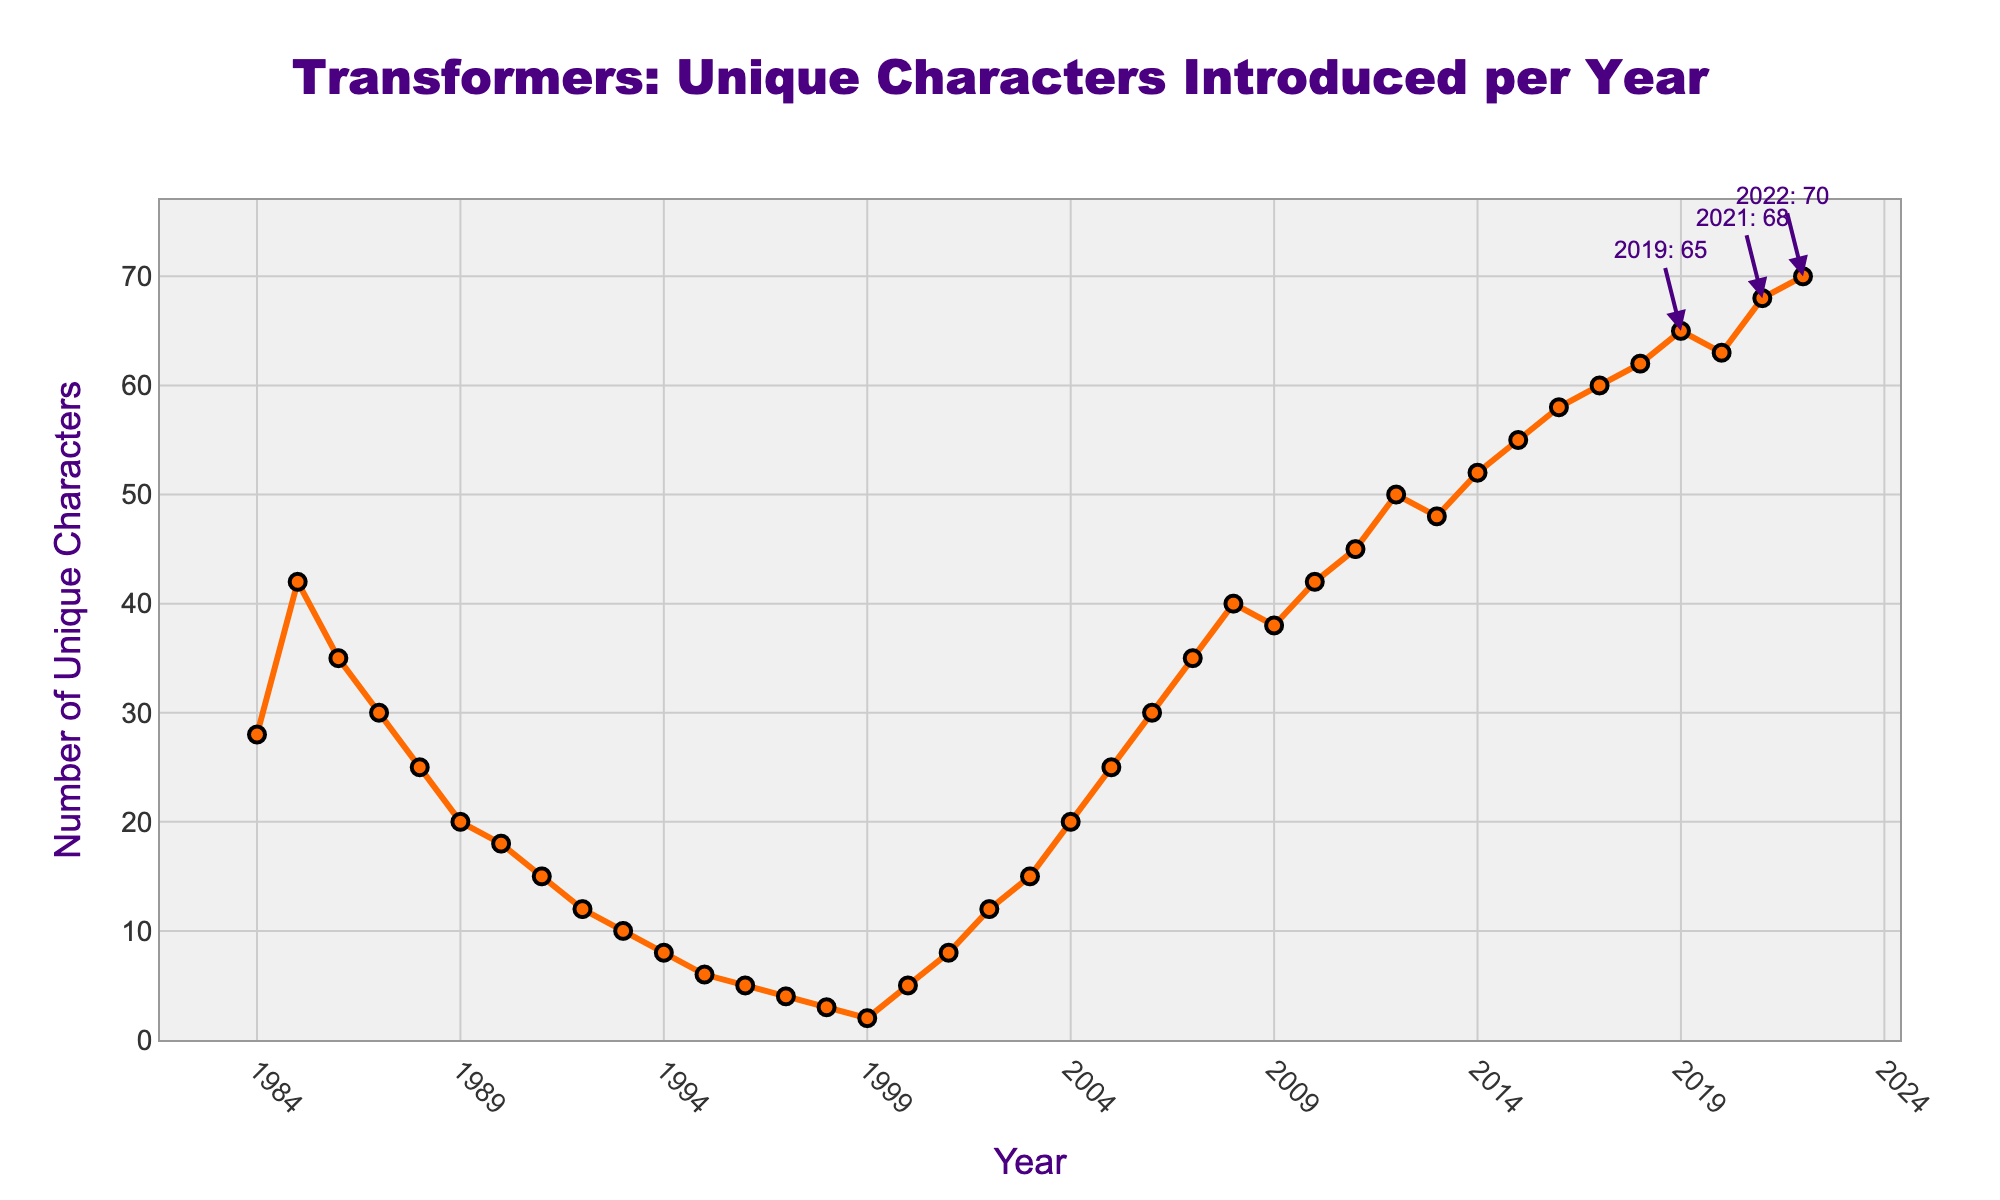What year had the highest number of unique Transformers characters introduced? According to the data, 2022 had the highest number of unique Transformers characters introduced, which is represented by the highest point on the line chart.
Answer: 2022 How many more unique characters were introduced in 2022 compared to 1984? In 1984, 28 unique characters were introduced and in 2022, 70 unique characters were introduced. The difference is 70 - 28 = 42.
Answer: 42 In which year range did the number of unique characters introduced stay relatively constant around 30? From 1986 to 1987 and again from 2005 to 2007, the number of unique characters introduced stayed relatively constant around 30, as indicated by the closely spaced points around the value 30 on the y-axis.
Answer: 1986-1987, 2005-2007 What are the three years with the smallest number of unique Transformers characters introduced? The three years with the smallest number of unique characters introduced are 1999 (2), 1998 (3), and 1997 (4), as indicated by the points closest to the x-axis.
Answer: 1999, 1998, 1997 Compare the overall trend from 1984 to 2022. How does it look? Initially, the number of unique characters decreased significantly from 1984 until around the mid-1990s, then there was some fluctuation followed by a significant increase starting from the early 2000s till 2022.
Answer: Decreasing then increasing Which year shows a spike in the number of unique characters introduced after a stable period? The year 2004 shows a spike after a relatively stable period in the late 1990s and early 2000s. In 2004, the number increased to 20.
Answer: 2004 What's the average number of unique characters introduced per year between 2000 and 2005? Sum the numbers from 2000 to 2005 (5+8+12+15+20+25 = 85). There are 6 years, so the average is 85 / 6 = 14.2.
Answer: 14.2 How does the number of unique characters introduced in 1991 compare to that in 2011? In 1991, 15 unique characters were introduced, whereas in 2011, 45 unique characters were introduced. Thus, 2011 had three times as many unique characters as 1991.
Answer: 2011 had 30 more Which years have a higher number of unique characters introduced than in 2005? Years that have a higher number of unique characters introduced than in 2005 (when it was 25) include all years from 2006 onwards, as the values continue to increase.
Answer: 2006 onwards What is the median number of unique characters introduced from 1984 to 2022? There are 39 data points. The median is the middle value, so the 20th value when sorted is 20.
Answer: 20 